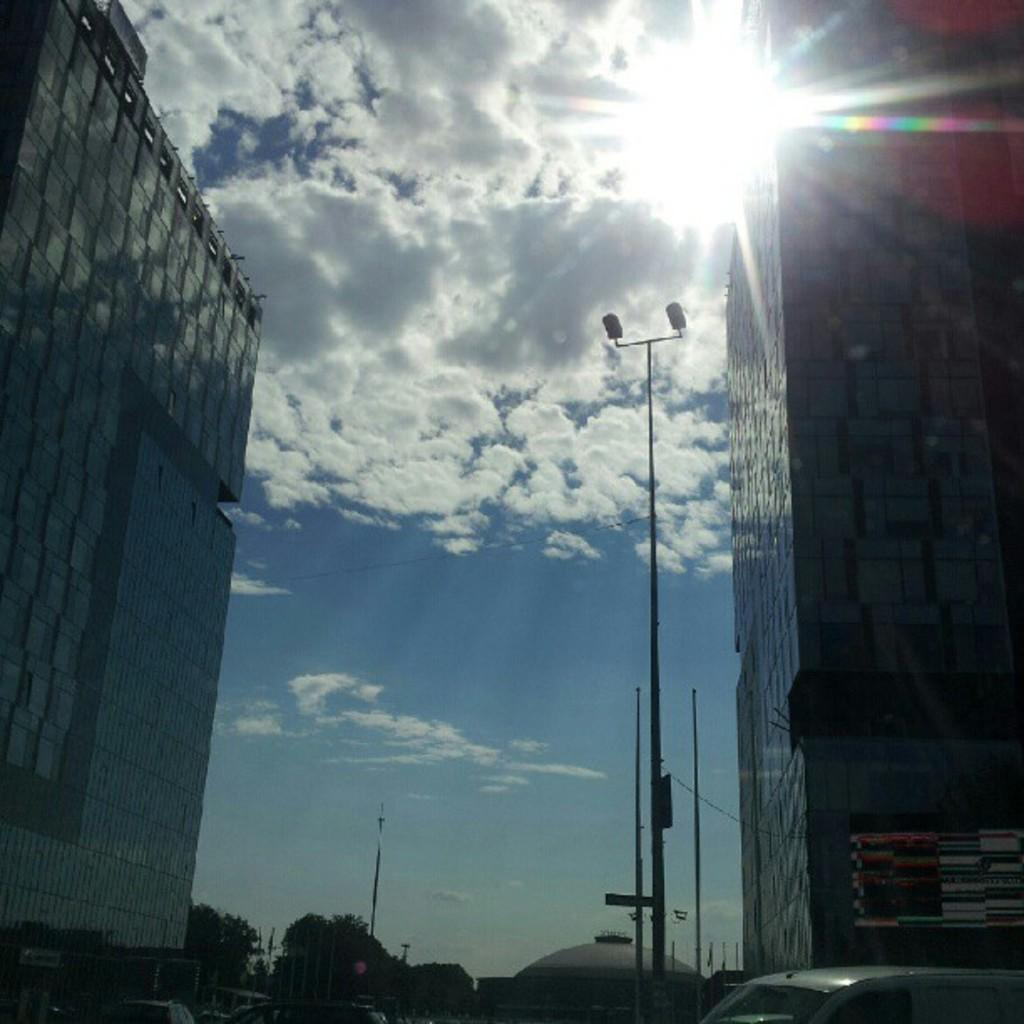What type of structures can be seen in the image? There are buildings in the image. What else is present in the image besides buildings? There are vehicles, trees, and street light poles in the image. What is the condition of the sky in the image? The sky is cloudy in the image. Can you see a ring on the street light pole in the image? There is no ring present on the street light pole in the image. Are there any nails visible on the trees in the image? There are no nails visible on the trees in the image. 